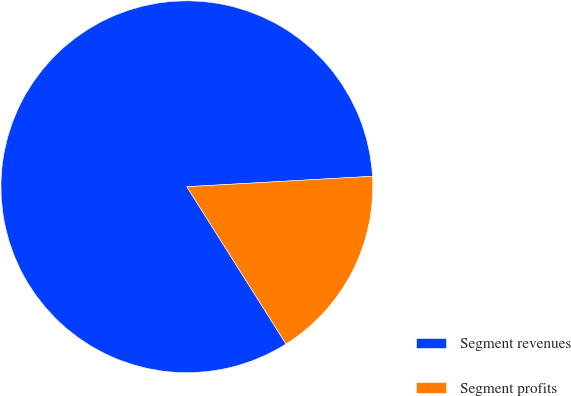Convert chart. <chart><loc_0><loc_0><loc_500><loc_500><pie_chart><fcel>Segment revenues<fcel>Segment profits<nl><fcel>83.06%<fcel>16.94%<nl></chart> 